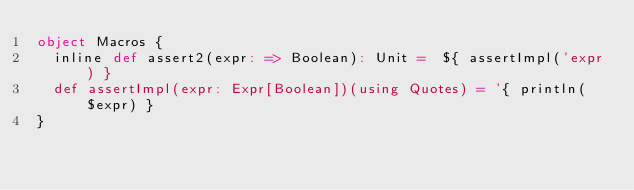Convert code to text. <code><loc_0><loc_0><loc_500><loc_500><_Scala_>object Macros {
  inline def assert2(expr: => Boolean): Unit =  ${ assertImpl('expr) }
  def assertImpl(expr: Expr[Boolean])(using Quotes) = '{ println($expr) }
}
</code> 